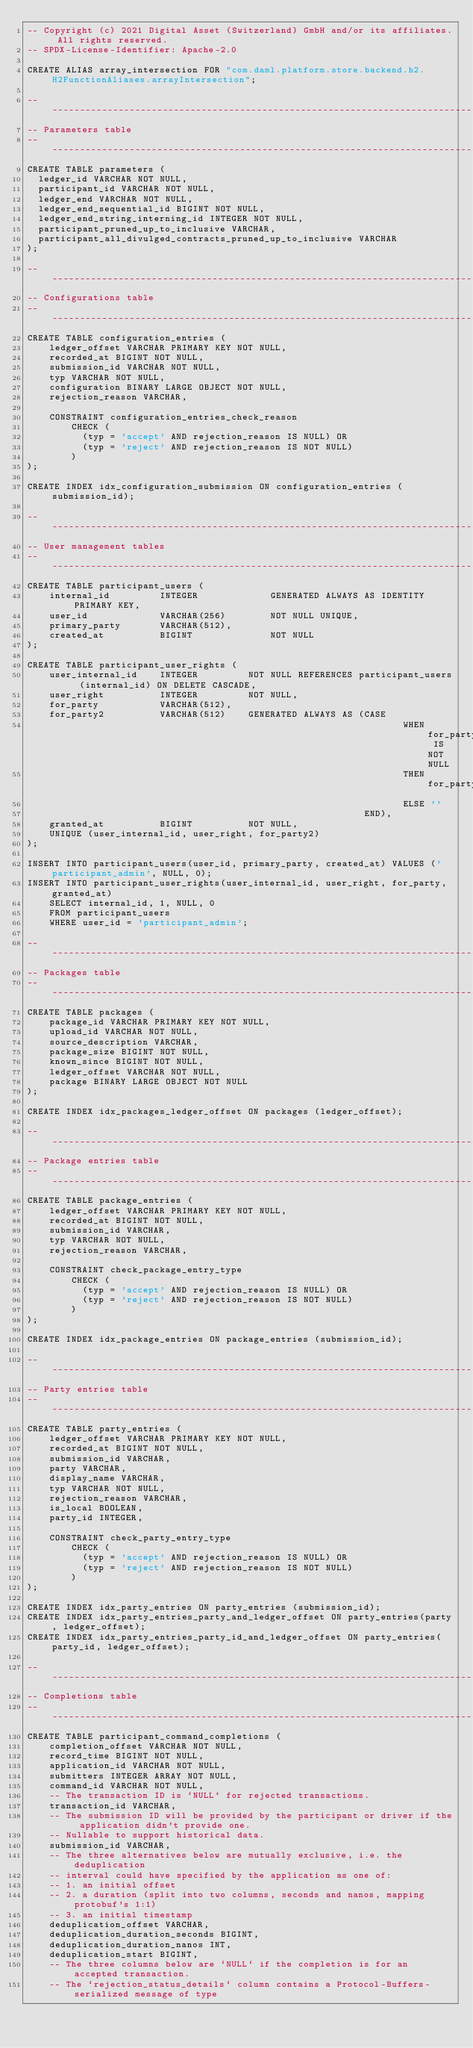<code> <loc_0><loc_0><loc_500><loc_500><_SQL_>-- Copyright (c) 2021 Digital Asset (Switzerland) GmbH and/or its affiliates. All rights reserved.
-- SPDX-License-Identifier: Apache-2.0

CREATE ALIAS array_intersection FOR "com.daml.platform.store.backend.h2.H2FunctionAliases.arrayIntersection";

---------------------------------------------------------------------------------------------------
-- Parameters table
---------------------------------------------------------------------------------------------------
CREATE TABLE parameters (
  ledger_id VARCHAR NOT NULL,
  participant_id VARCHAR NOT NULL,
  ledger_end VARCHAR NOT NULL,
  ledger_end_sequential_id BIGINT NOT NULL,
  ledger_end_string_interning_id INTEGER NOT NULL,
  participant_pruned_up_to_inclusive VARCHAR,
  participant_all_divulged_contracts_pruned_up_to_inclusive VARCHAR
);

---------------------------------------------------------------------------------------------------
-- Configurations table
---------------------------------------------------------------------------------------------------
CREATE TABLE configuration_entries (
    ledger_offset VARCHAR PRIMARY KEY NOT NULL,
    recorded_at BIGINT NOT NULL,
    submission_id VARCHAR NOT NULL,
    typ VARCHAR NOT NULL,
    configuration BINARY LARGE OBJECT NOT NULL,
    rejection_reason VARCHAR,

    CONSTRAINT configuration_entries_check_reason
        CHECK (
          (typ = 'accept' AND rejection_reason IS NULL) OR
          (typ = 'reject' AND rejection_reason IS NOT NULL)
        )
);

CREATE INDEX idx_configuration_submission ON configuration_entries (submission_id);

---------------------------------------------------------------------------------------------------
-- User management tables
---------------------------------------------------------------------------------------------------
CREATE TABLE participant_users (
    internal_id         INTEGER             GENERATED ALWAYS AS IDENTITY PRIMARY KEY,
    user_id             VARCHAR(256)        NOT NULL UNIQUE,
    primary_party       VARCHAR(512),
    created_at          BIGINT              NOT NULL
);

CREATE TABLE participant_user_rights (
    user_internal_id    INTEGER         NOT NULL REFERENCES participant_users (internal_id) ON DELETE CASCADE,
    user_right          INTEGER         NOT NULL,
    for_party           VARCHAR(512),
    for_party2          VARCHAR(512)    GENERATED ALWAYS AS (CASE
                                                                    WHEN for_party IS NOT NULL
                                                                    THEN for_party
                                                                    ELSE ''
                                                             END),
    granted_at          BIGINT          NOT NULL,
    UNIQUE (user_internal_id, user_right, for_party2)
);

INSERT INTO participant_users(user_id, primary_party, created_at) VALUES ('participant_admin', NULL, 0);
INSERT INTO participant_user_rights(user_internal_id, user_right, for_party, granted_at)
    SELECT internal_id, 1, NULL, 0
    FROM participant_users
    WHERE user_id = 'participant_admin';

---------------------------------------------------------------------------------------------------
-- Packages table
---------------------------------------------------------------------------------------------------
CREATE TABLE packages (
    package_id VARCHAR PRIMARY KEY NOT NULL,
    upload_id VARCHAR NOT NULL,
    source_description VARCHAR,
    package_size BIGINT NOT NULL,
    known_since BIGINT NOT NULL,
    ledger_offset VARCHAR NOT NULL,
    package BINARY LARGE OBJECT NOT NULL
);

CREATE INDEX idx_packages_ledger_offset ON packages (ledger_offset);

---------------------------------------------------------------------------------------------------
-- Package entries table
---------------------------------------------------------------------------------------------------
CREATE TABLE package_entries (
    ledger_offset VARCHAR PRIMARY KEY NOT NULL,
    recorded_at BIGINT NOT NULL,
    submission_id VARCHAR,
    typ VARCHAR NOT NULL,
    rejection_reason VARCHAR,

    CONSTRAINT check_package_entry_type
        CHECK (
          (typ = 'accept' AND rejection_reason IS NULL) OR
          (typ = 'reject' AND rejection_reason IS NOT NULL)
        )
);

CREATE INDEX idx_package_entries ON package_entries (submission_id);

---------------------------------------------------------------------------------------------------
-- Party entries table
---------------------------------------------------------------------------------------------------
CREATE TABLE party_entries (
    ledger_offset VARCHAR PRIMARY KEY NOT NULL,
    recorded_at BIGINT NOT NULL,
    submission_id VARCHAR,
    party VARCHAR,
    display_name VARCHAR,
    typ VARCHAR NOT NULL,
    rejection_reason VARCHAR,
    is_local BOOLEAN,
    party_id INTEGER,

    CONSTRAINT check_party_entry_type
        CHECK (
          (typ = 'accept' AND rejection_reason IS NULL) OR
          (typ = 'reject' AND rejection_reason IS NOT NULL)
        )
);

CREATE INDEX idx_party_entries ON party_entries (submission_id);
CREATE INDEX idx_party_entries_party_and_ledger_offset ON party_entries(party, ledger_offset);
CREATE INDEX idx_party_entries_party_id_and_ledger_offset ON party_entries(party_id, ledger_offset);

---------------------------------------------------------------------------------------------------
-- Completions table
---------------------------------------------------------------------------------------------------
CREATE TABLE participant_command_completions (
    completion_offset VARCHAR NOT NULL,
    record_time BIGINT NOT NULL,
    application_id VARCHAR NOT NULL,
    submitters INTEGER ARRAY NOT NULL,
    command_id VARCHAR NOT NULL,
    -- The transaction ID is `NULL` for rejected transactions.
    transaction_id VARCHAR,
    -- The submission ID will be provided by the participant or driver if the application didn't provide one.
    -- Nullable to support historical data.
    submission_id VARCHAR,
    -- The three alternatives below are mutually exclusive, i.e. the deduplication
    -- interval could have specified by the application as one of:
    -- 1. an initial offset
    -- 2. a duration (split into two columns, seconds and nanos, mapping protobuf's 1:1)
    -- 3. an initial timestamp
    deduplication_offset VARCHAR,
    deduplication_duration_seconds BIGINT,
    deduplication_duration_nanos INT,
    deduplication_start BIGINT,
    -- The three columns below are `NULL` if the completion is for an accepted transaction.
    -- The `rejection_status_details` column contains a Protocol-Buffers-serialized message of type</code> 